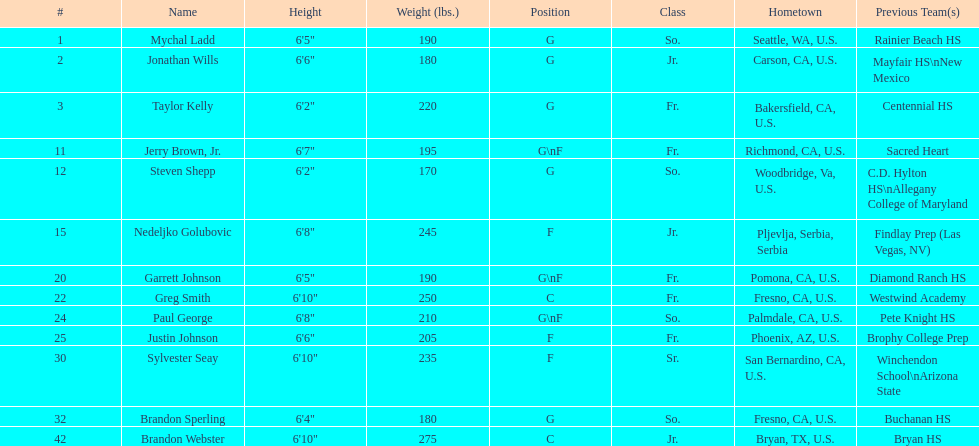Among forwards (f) only, which player has the least height? Justin Johnson. 